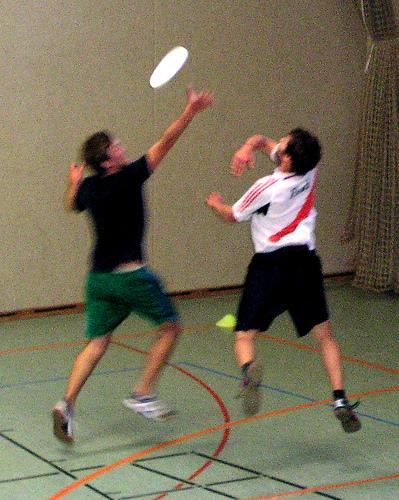Provide a short analysis of the actions between the primary objects and the people in the image. In the image, two men are jumping towards each other trying to catch a white frisbee mid-air, signifying an actively engaging sports scene. Mention an object in the air within the image. A frisbee. What color are the shoes worn by the person in the blue and white shoe image? The shoes are blue and white. Identify the object that two men are interacting with in the image. Two men are playing with a white frisbee. List the colors of the shorts worn by the two men in the image. Green and black. What is the color of the frisbee being played with in the image? The frisbee is white. Which action can be observed in the picture, involving two people? Two guys are playing frisbee. What is unique about the hair of the man within the "man has black hair" image? The man has black hair. What is the color of the shirt worn by the person in the "man has black shirt" image? The shirt is black. Briefly describe the scene depicted in the image. The image shows two men jumping to catch a white frisbee while wearing different colored shirts, shorts, and shoes. There are black lines on the floor and various other details. Which team is winning the soccer match? The image only describes two individuals playing frisbee, not a soccer match with teams. Introducing a whole new setting is misleading and may cause confusion. Find the sunglasses that one of the men is wearing. No, it's not mentioned in the image. 